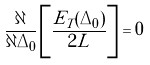Convert formula to latex. <formula><loc_0><loc_0><loc_500><loc_500>\frac { \partial } { \partial \Delta _ { 0 } } \left [ \frac { E _ { T } ( \Delta _ { 0 } ) } { 2 L } \right ] = 0</formula> 